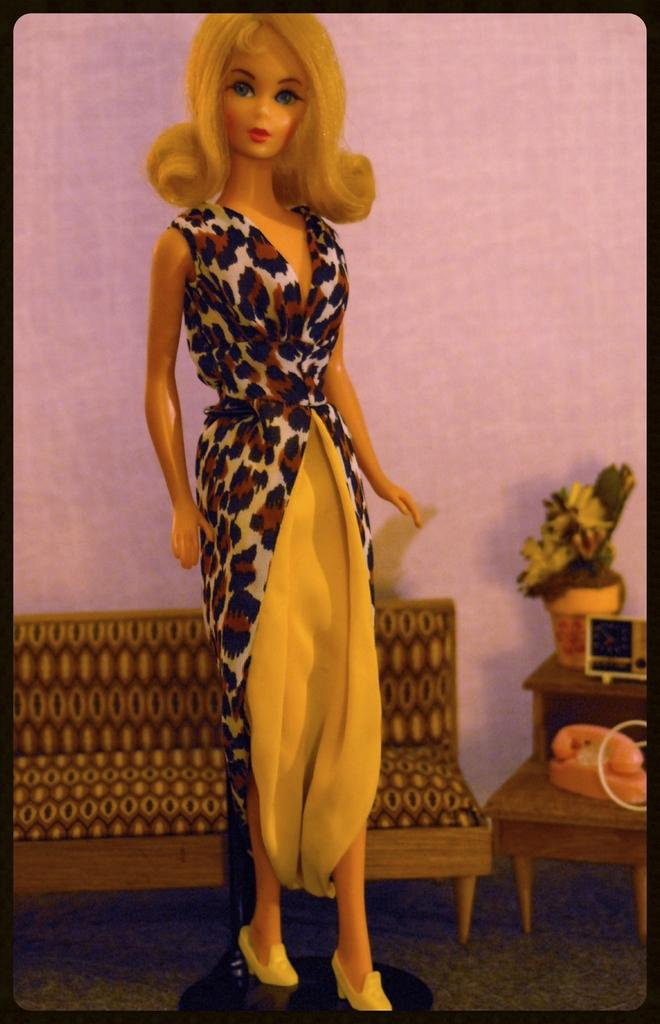What is the main subject in the center of the image? There is a doll in the center of the image. What furniture can be seen in the background of the image? There is a chair and a stool in the background of the image. What electronic device is present in the background of the image? There is a phone in the background of the image. What type of plant container is visible in the background of the image? There is a flower pot in the background of the image. What other object can be seen in the background of the image? There is an object in the background of the image. What type of surface is at the bottom of the image? There is a floor at the bottom of the image. What type of wall is visible in the background of the image? There is a wall in the background of the image. What type of form does the achiever fill out in the image? There is no form or achiever present in the image. 